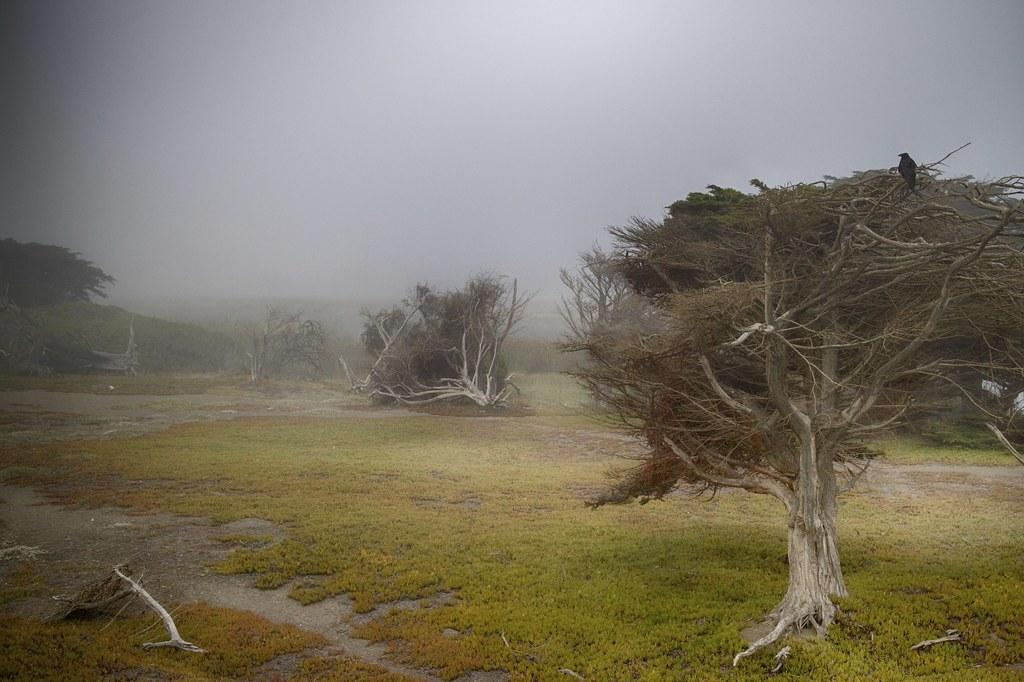What type of vegetation can be seen in the image? There are trees in the image. What else can be seen on the ground in the image? There is grass in the image. What is visible in the background of the image? The sky is visible in the background of the image. How does the pig contribute to the knowledge displayed in the image? There is no pig present in the image, so it cannot contribute to the knowledge displayed. 